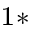<formula> <loc_0><loc_0><loc_500><loc_500>^ { 1 * }</formula> 